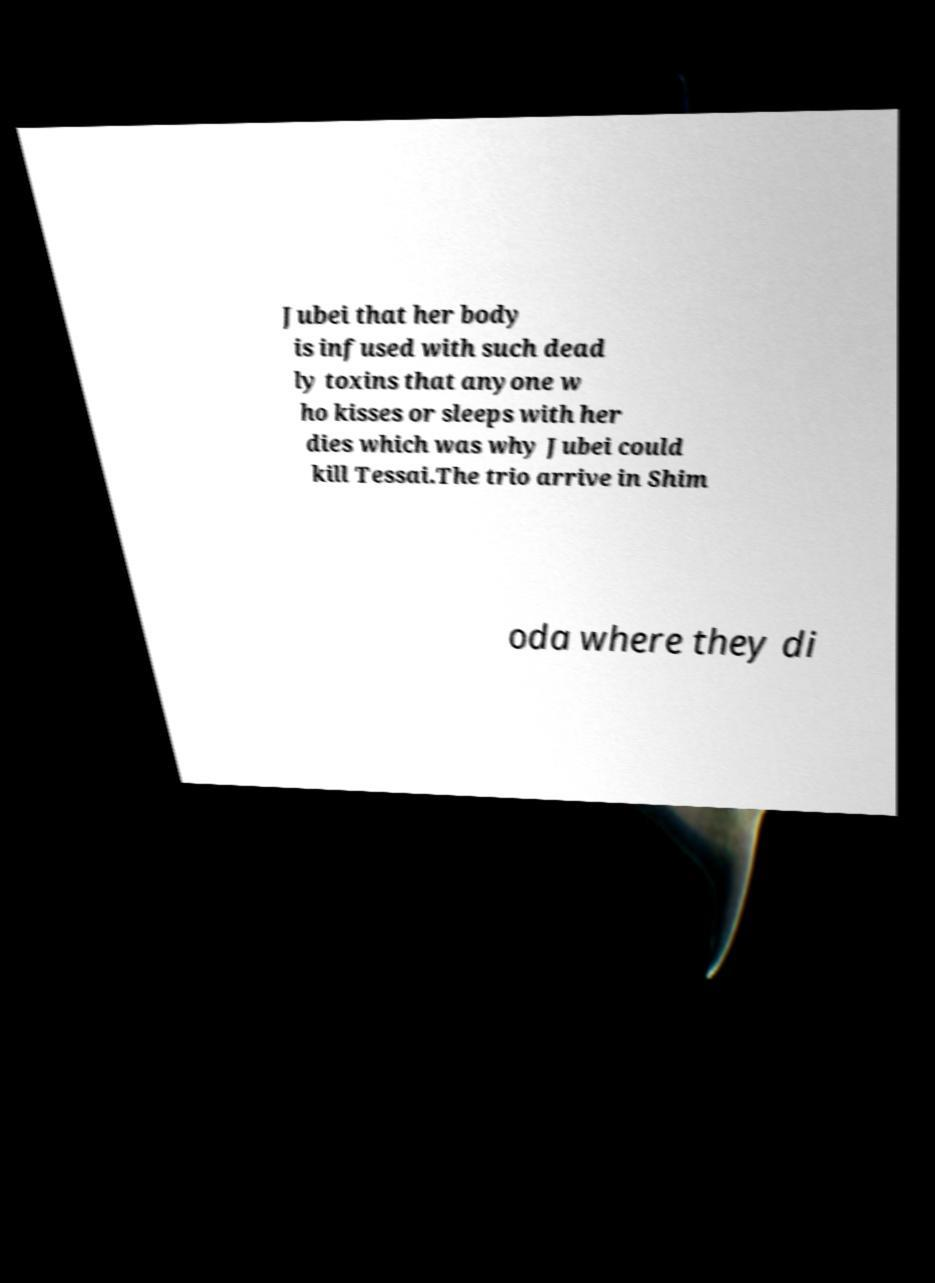Please identify and transcribe the text found in this image. Jubei that her body is infused with such dead ly toxins that anyone w ho kisses or sleeps with her dies which was why Jubei could kill Tessai.The trio arrive in Shim oda where they di 